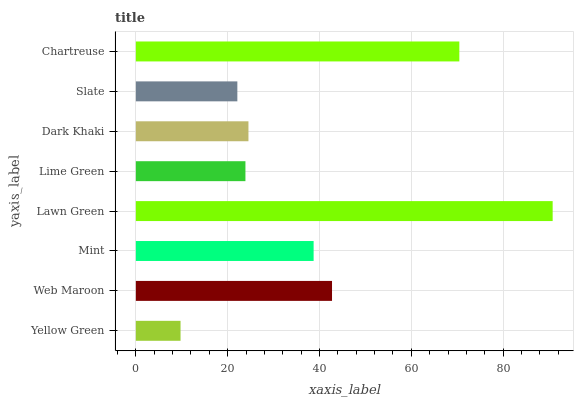Is Yellow Green the minimum?
Answer yes or no. Yes. Is Lawn Green the maximum?
Answer yes or no. Yes. Is Web Maroon the minimum?
Answer yes or no. No. Is Web Maroon the maximum?
Answer yes or no. No. Is Web Maroon greater than Yellow Green?
Answer yes or no. Yes. Is Yellow Green less than Web Maroon?
Answer yes or no. Yes. Is Yellow Green greater than Web Maroon?
Answer yes or no. No. Is Web Maroon less than Yellow Green?
Answer yes or no. No. Is Mint the high median?
Answer yes or no. Yes. Is Dark Khaki the low median?
Answer yes or no. Yes. Is Lime Green the high median?
Answer yes or no. No. Is Chartreuse the low median?
Answer yes or no. No. 